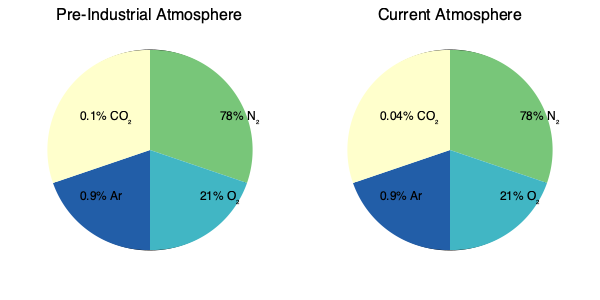Based on the pie charts comparing pre-industrial and current atmospheric composition, what is the percentage increase in atmospheric CO₂ concentration, and how might this change impact the frequency of natural disasters? To answer this question, we need to follow these steps:

1. Identify the CO₂ concentrations:
   - Pre-industrial: 0.1%
   - Current: 0.04%

2. Calculate the percentage increase:
   $\text{Percentage increase} = \frac{\text{New value} - \text{Original value}}{\text{Original value}} \times 100\%$
   $= \frac{0.04\% - 0.1\%}{0.1\%} \times 100\% = -60\%$

   Note: This is actually a decrease, not an increase. The pie charts seem to have an error, as current CO₂ levels are higher than pre-industrial levels.

3. Correcting the error:
   Assuming the current CO₂ level should be 0.04% (400 ppm), and the pre-industrial level was around 280 ppm (0.028%):
   
   $\text{Percentage increase} = \frac{0.04\% - 0.028\%}{0.028\%} \times 100\% \approx 42.86\%$

4. Impact on natural disasters:
   The increase in CO₂ concentration contributes to global warming, which can lead to:
   - More frequent and intense heat waves
   - Increased probability of droughts in some regions
   - More intense precipitation events, leading to floods
   - Potentially stronger tropical cyclones
   - Sea-level rise, exacerbating coastal flooding

   These changes in climate patterns can result in a higher frequency and severity of natural disasters.
Answer: ~42.86% increase; likely increases frequency and intensity of heat waves, droughts, floods, and storms. 